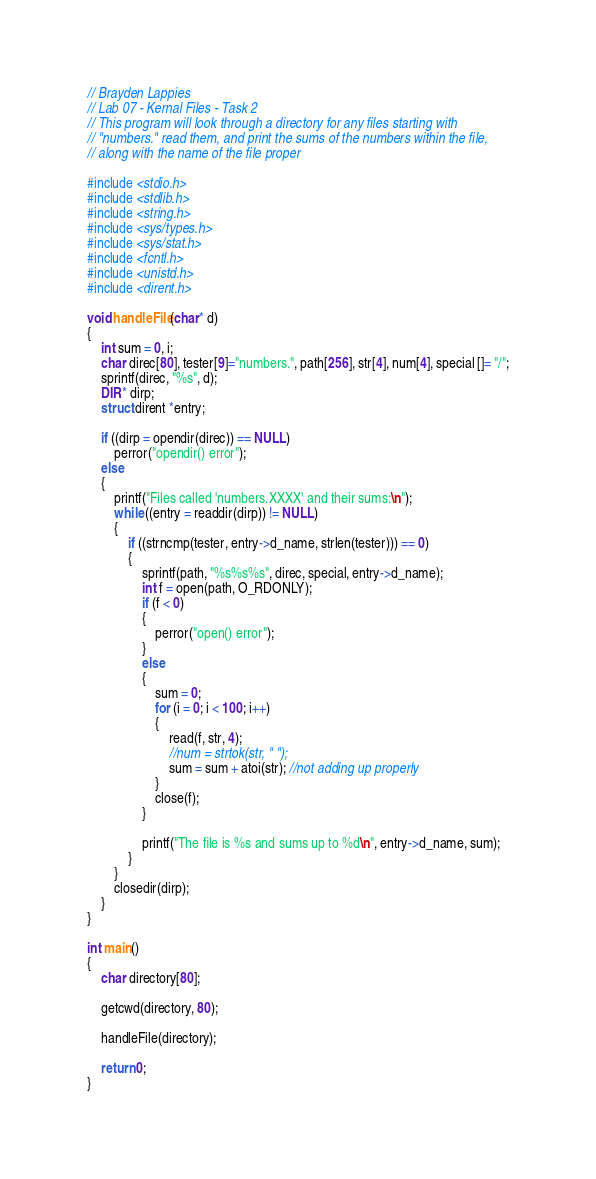Convert code to text. <code><loc_0><loc_0><loc_500><loc_500><_C_>// Brayden Lappies
// Lab 07 - Kernal Files - Task 2
// This program will look through a directory for any files starting with
// "numbers." read them, and print the sums of the numbers within the file,
// along with the name of the file proper

#include <stdio.h>
#include <stdlib.h>
#include <string.h>
#include <sys/types.h>
#include <sys/stat.h>
#include <fcntl.h>
#include <unistd.h>
#include <dirent.h>

void handleFile(char* d)
{
	int sum = 0, i;
	char direc[80], tester[9]="numbers.", path[256], str[4], num[4], special []= "/";
	sprintf(direc, "%s", d);
	DIR* dirp;
	struct dirent *entry;
	
	if ((dirp = opendir(direc)) == NULL)
		perror("opendir() error");
	else
	{
		printf("Files called 'numbers.XXXX' and their sums:\n");
		while ((entry = readdir(dirp)) != NULL)
		{
			if ((strncmp(tester, entry->d_name, strlen(tester))) == 0)
			{
				sprintf(path, "%s%s%s", direc, special, entry->d_name);
				int f = open(path, O_RDONLY);
				if (f < 0)
				{
					perror("open() error");
				}
				else
				{
					sum = 0;
					for (i = 0; i < 100; i++)
					{
						read(f, str, 4);
						//num = strtok(str, " ");
						sum = sum + atoi(str); //not adding up properly
					}
					close(f);
				}
				
				printf("The file is %s and sums up to %d\n", entry->d_name, sum);
			}
		}
		closedir(dirp);
	}
}

int main()
{
	char directory[80];
	
	getcwd(directory, 80);
	
	handleFile(directory);
	
	return 0;
}</code> 